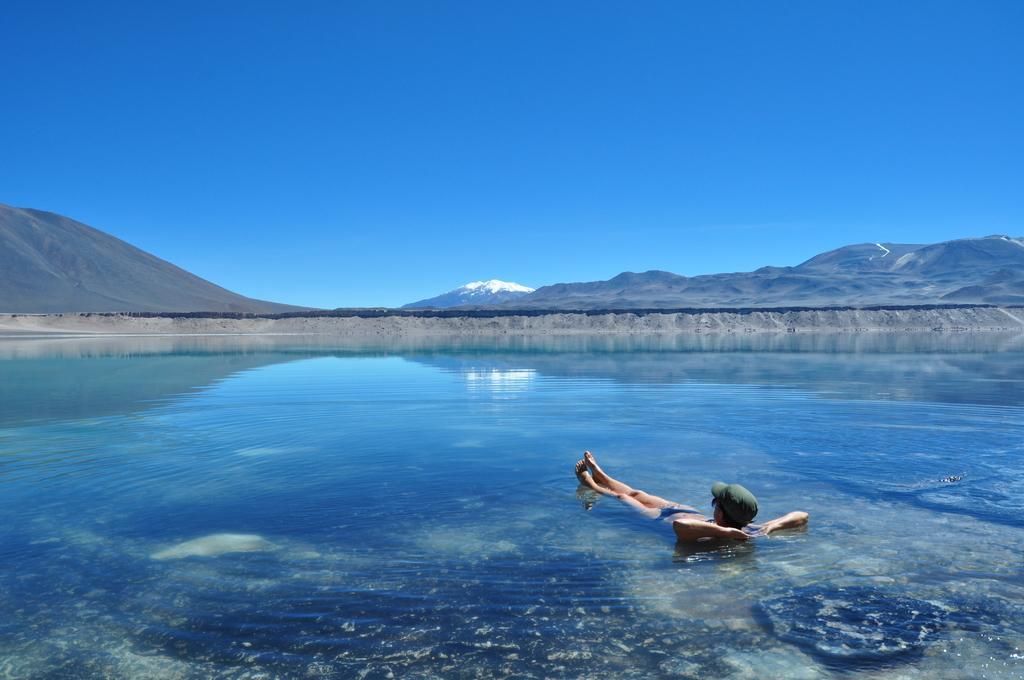Describe this image in one or two sentences. In this image we can see sky, hills, mountains, and, river and a person in the water. 